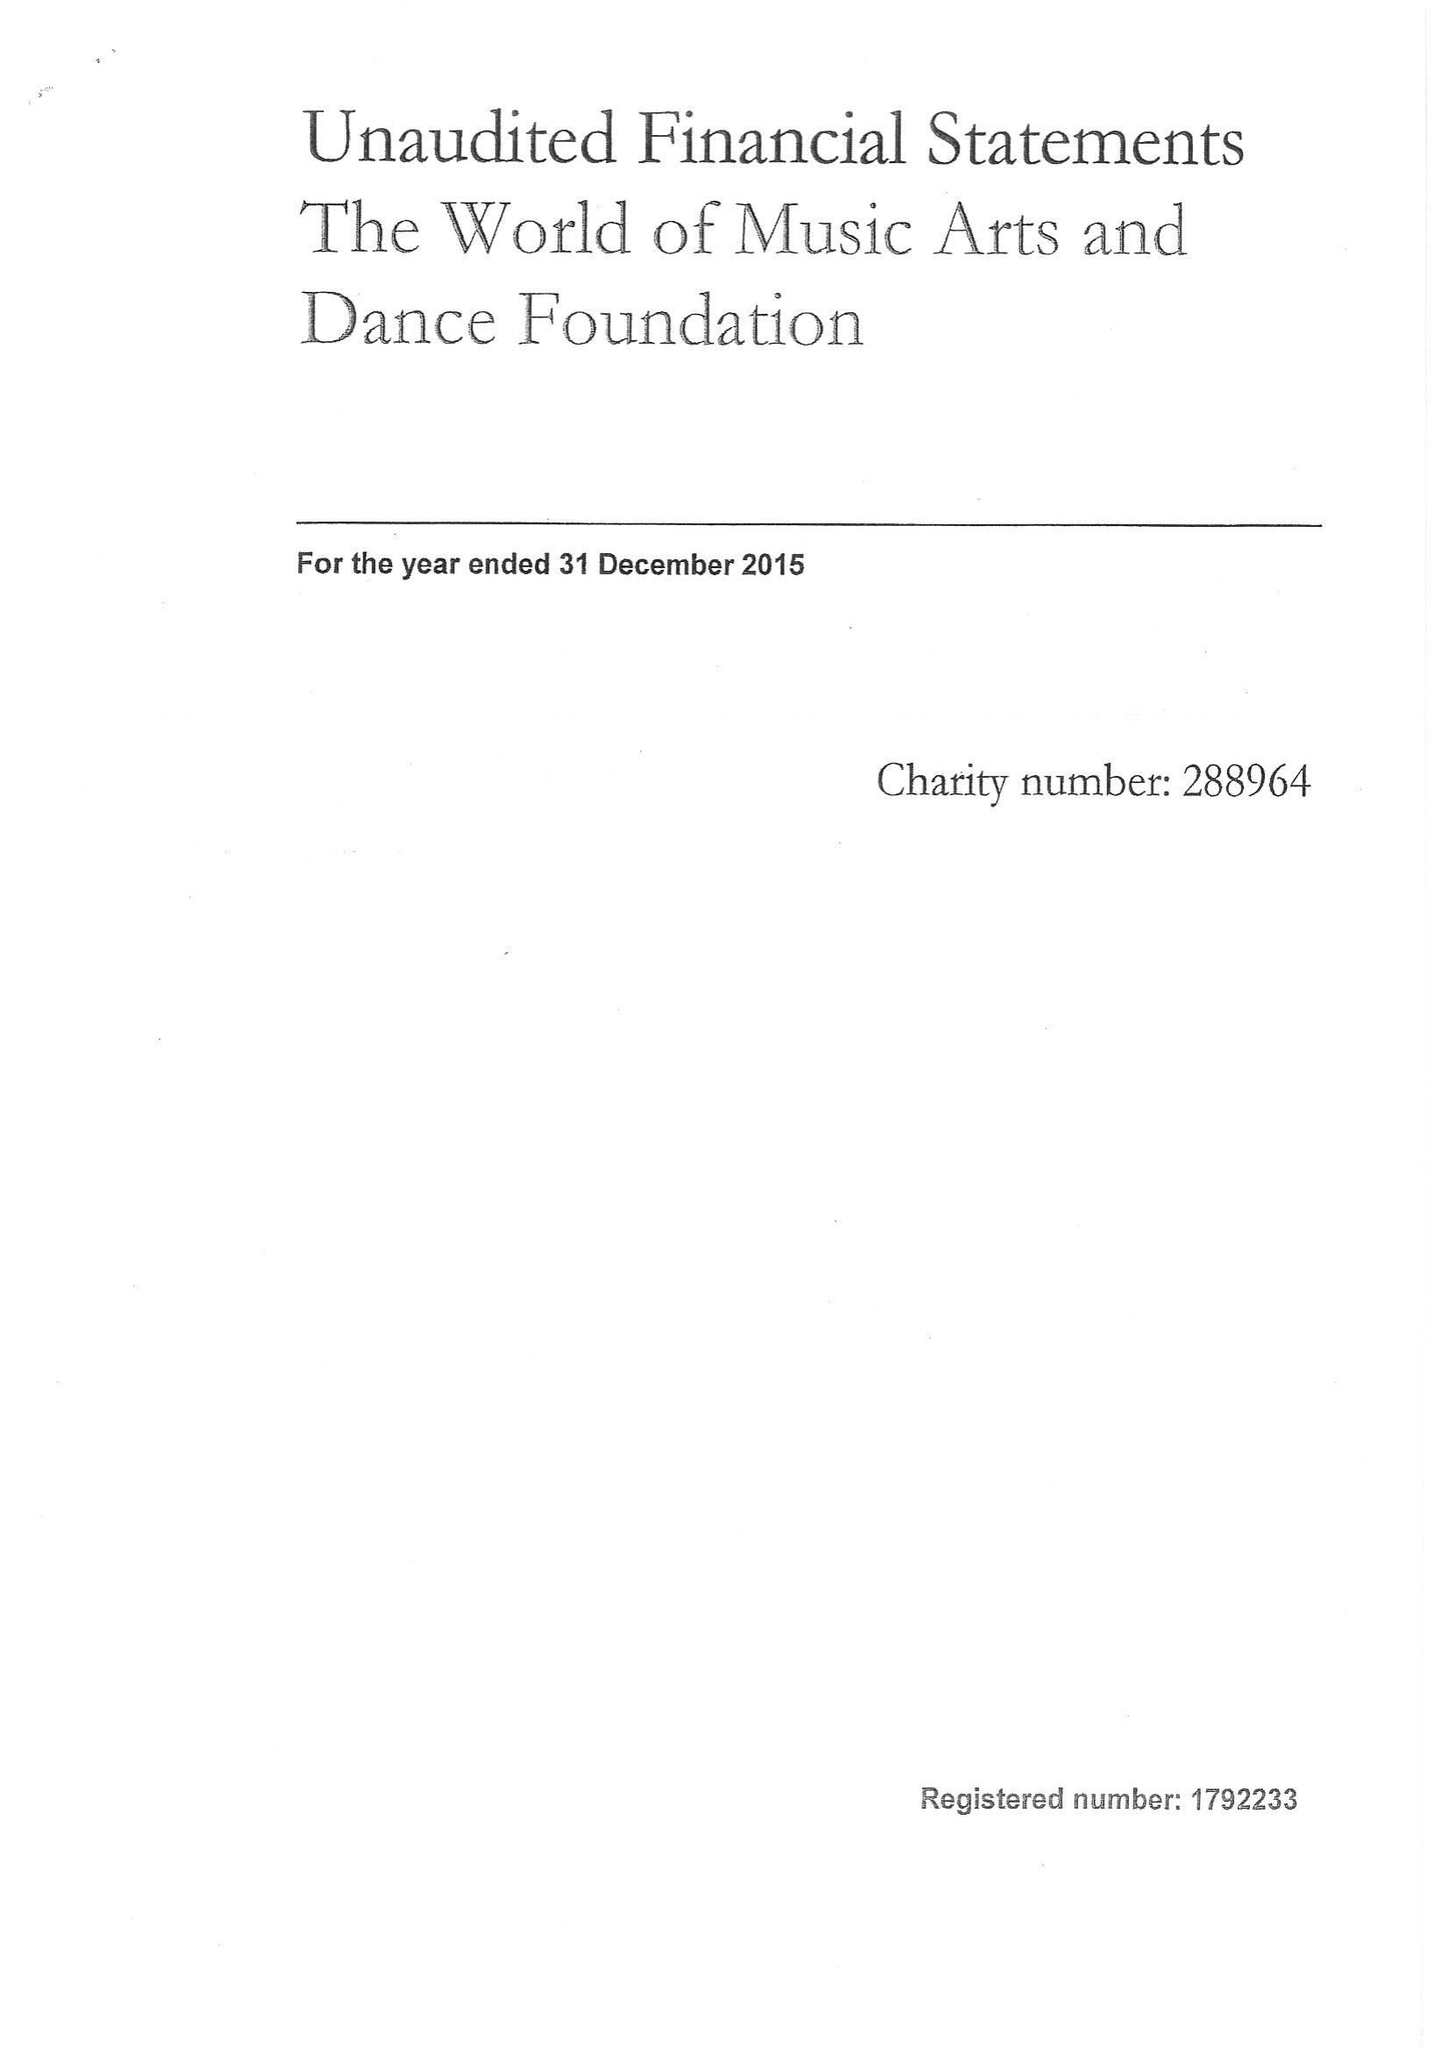What is the value for the address__street_line?
Answer the question using a single word or phrase. MILL LANE 